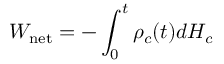Convert formula to latex. <formula><loc_0><loc_0><loc_500><loc_500>W _ { n e t } = - \int _ { 0 } ^ { t } \rho _ { c } ( t ) d H _ { c }</formula> 